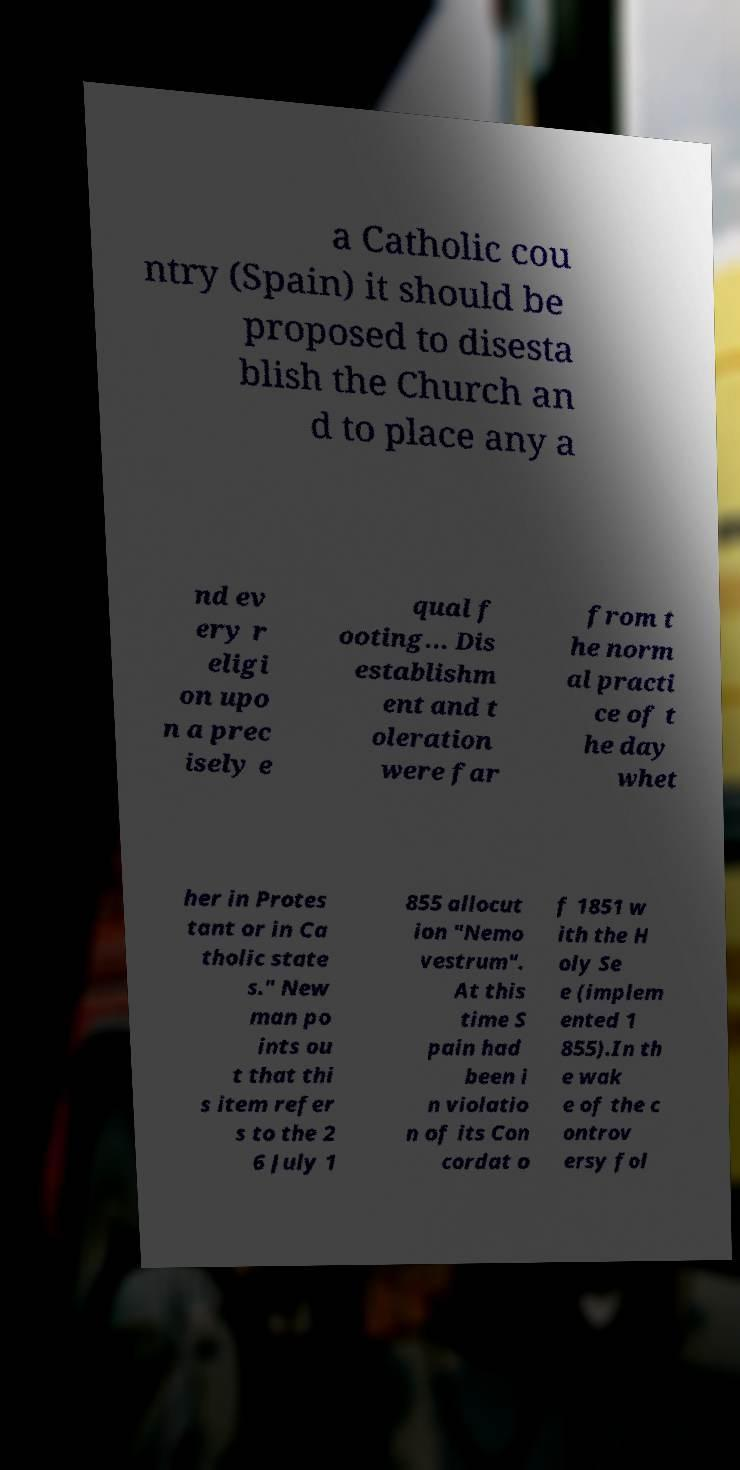Can you accurately transcribe the text from the provided image for me? a Catholic cou ntry (Spain) it should be proposed to disesta blish the Church an d to place any a nd ev ery r eligi on upo n a prec isely e qual f ooting... Dis establishm ent and t oleration were far from t he norm al practi ce of t he day whet her in Protes tant or in Ca tholic state s." New man po ints ou t that thi s item refer s to the 2 6 July 1 855 allocut ion "Nemo vestrum". At this time S pain had been i n violatio n of its Con cordat o f 1851 w ith the H oly Se e (implem ented 1 855).In th e wak e of the c ontrov ersy fol 